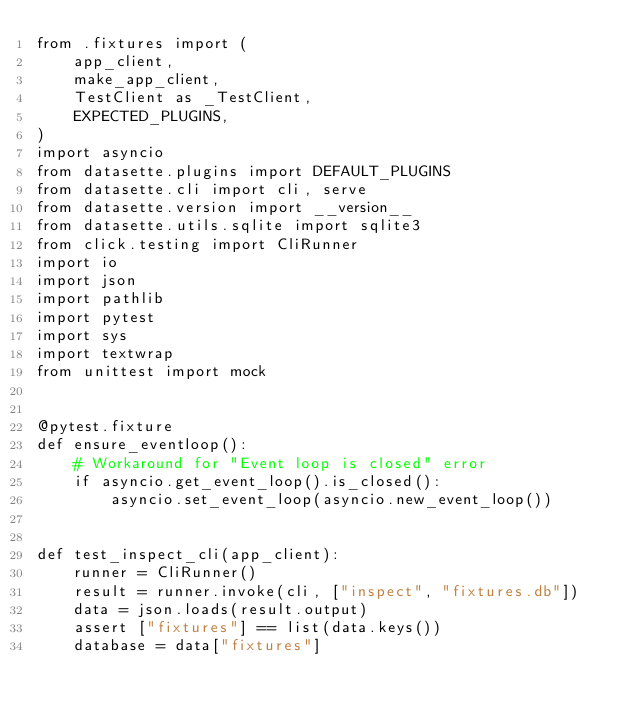Convert code to text. <code><loc_0><loc_0><loc_500><loc_500><_Python_>from .fixtures import (
    app_client,
    make_app_client,
    TestClient as _TestClient,
    EXPECTED_PLUGINS,
)
import asyncio
from datasette.plugins import DEFAULT_PLUGINS
from datasette.cli import cli, serve
from datasette.version import __version__
from datasette.utils.sqlite import sqlite3
from click.testing import CliRunner
import io
import json
import pathlib
import pytest
import sys
import textwrap
from unittest import mock


@pytest.fixture
def ensure_eventloop():
    # Workaround for "Event loop is closed" error
    if asyncio.get_event_loop().is_closed():
        asyncio.set_event_loop(asyncio.new_event_loop())


def test_inspect_cli(app_client):
    runner = CliRunner()
    result = runner.invoke(cli, ["inspect", "fixtures.db"])
    data = json.loads(result.output)
    assert ["fixtures"] == list(data.keys())
    database = data["fixtures"]</code> 